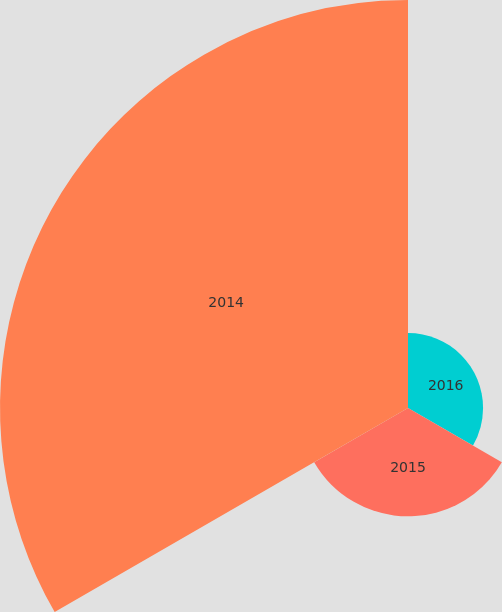Convert chart to OTSL. <chart><loc_0><loc_0><loc_500><loc_500><pie_chart><fcel>2016<fcel>2015<fcel>2014<nl><fcel>12.69%<fcel>18.32%<fcel>68.99%<nl></chart> 